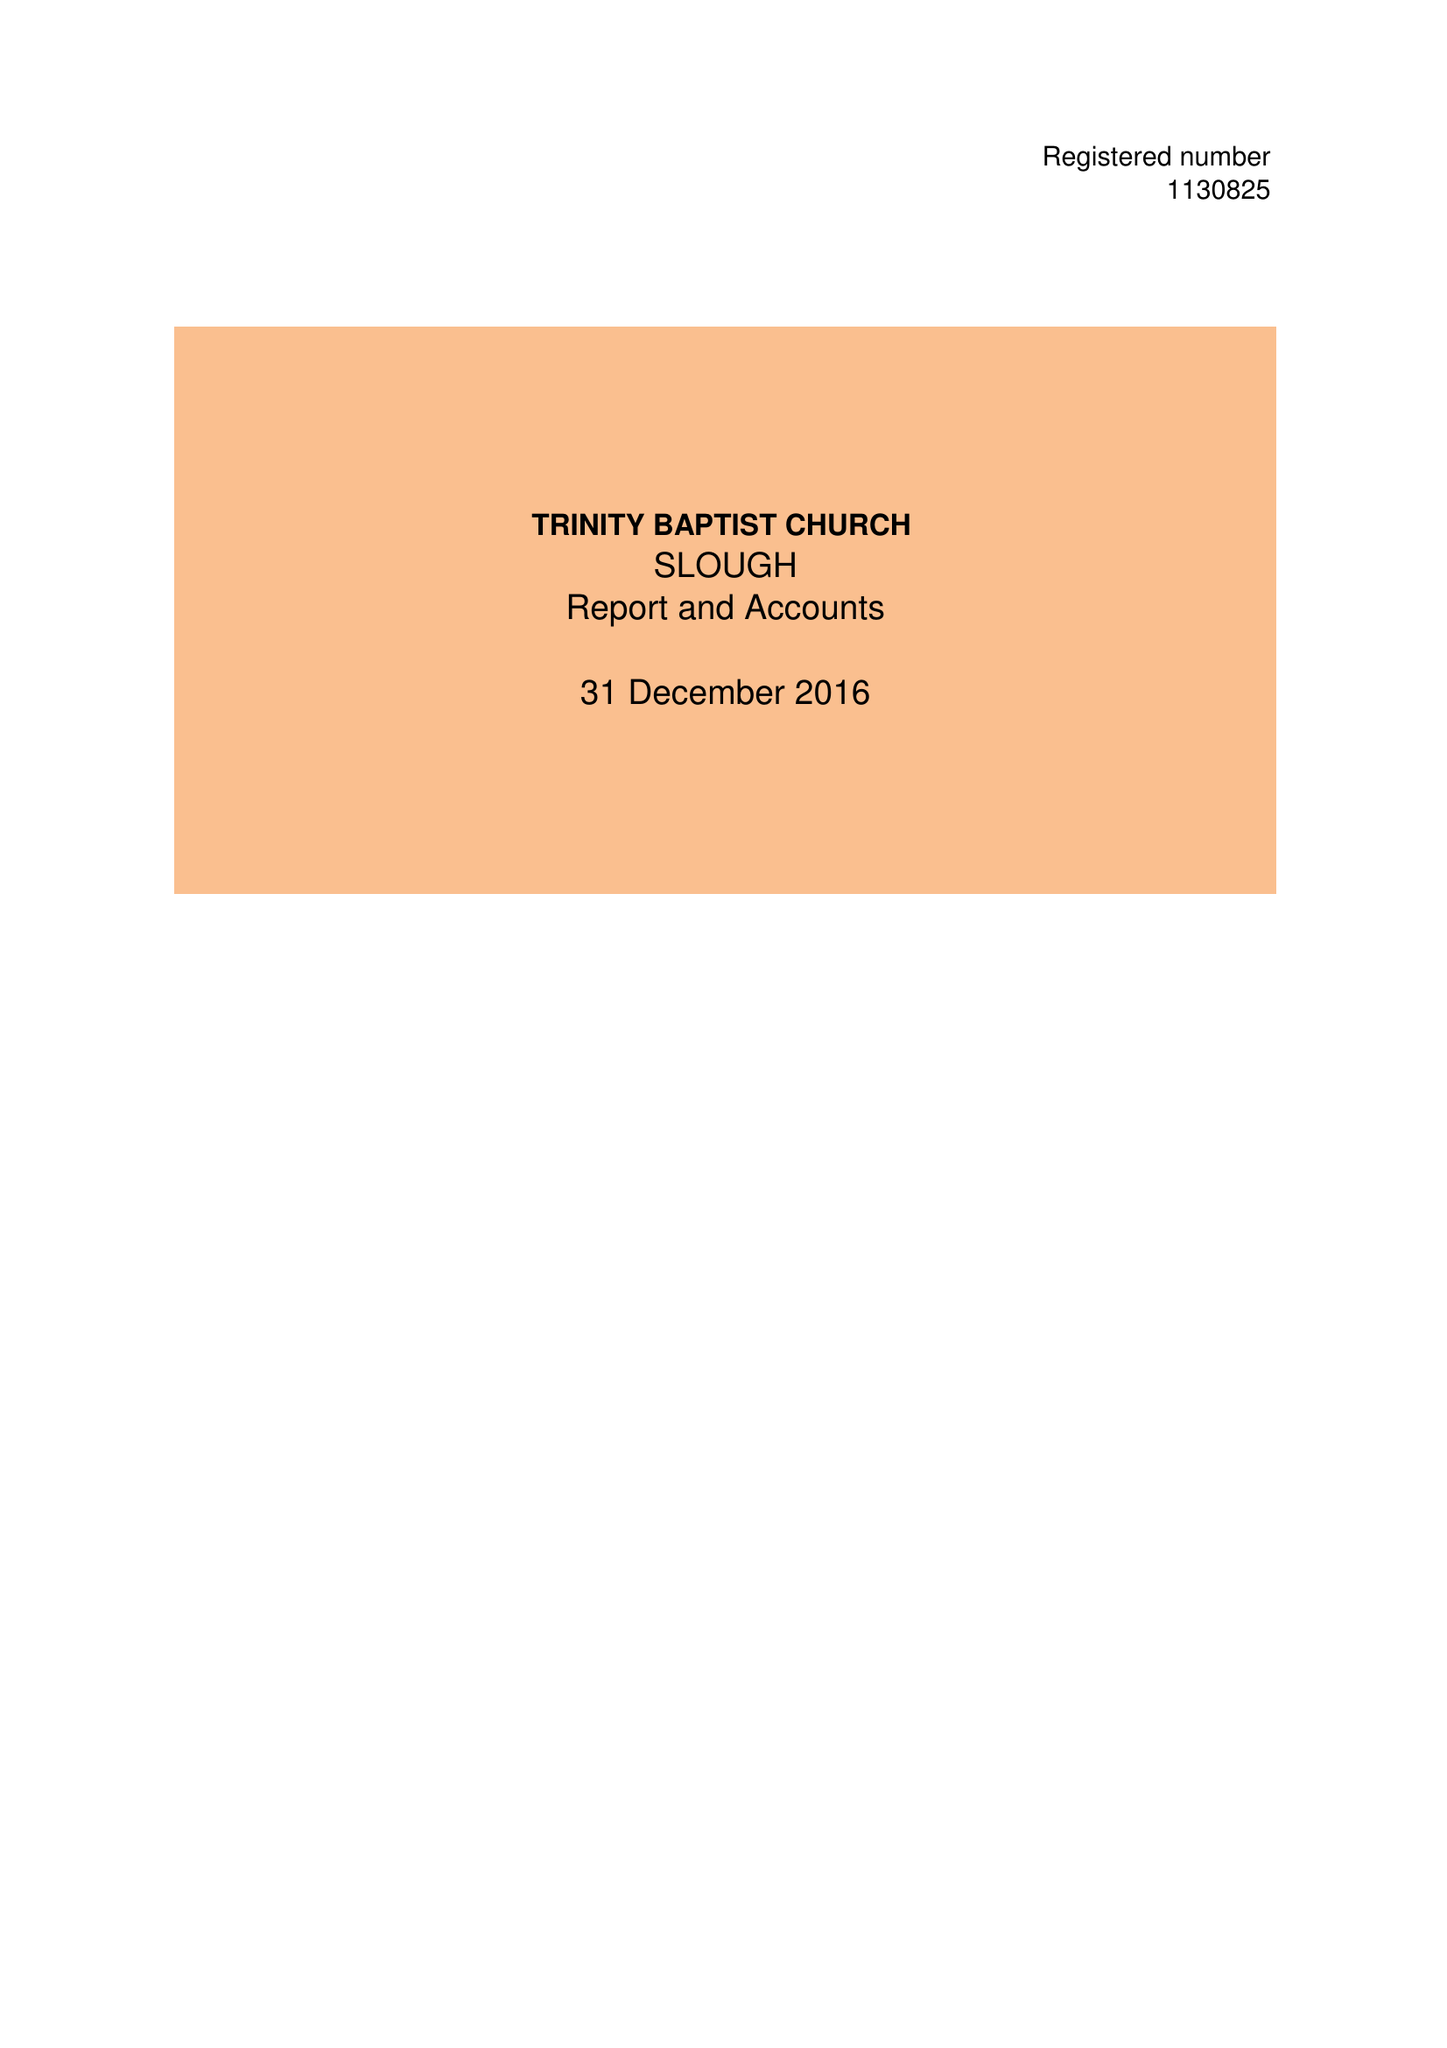What is the value for the address__street_line?
Answer the question using a single word or phrase. 1-5 GLADSTONE ROAD 